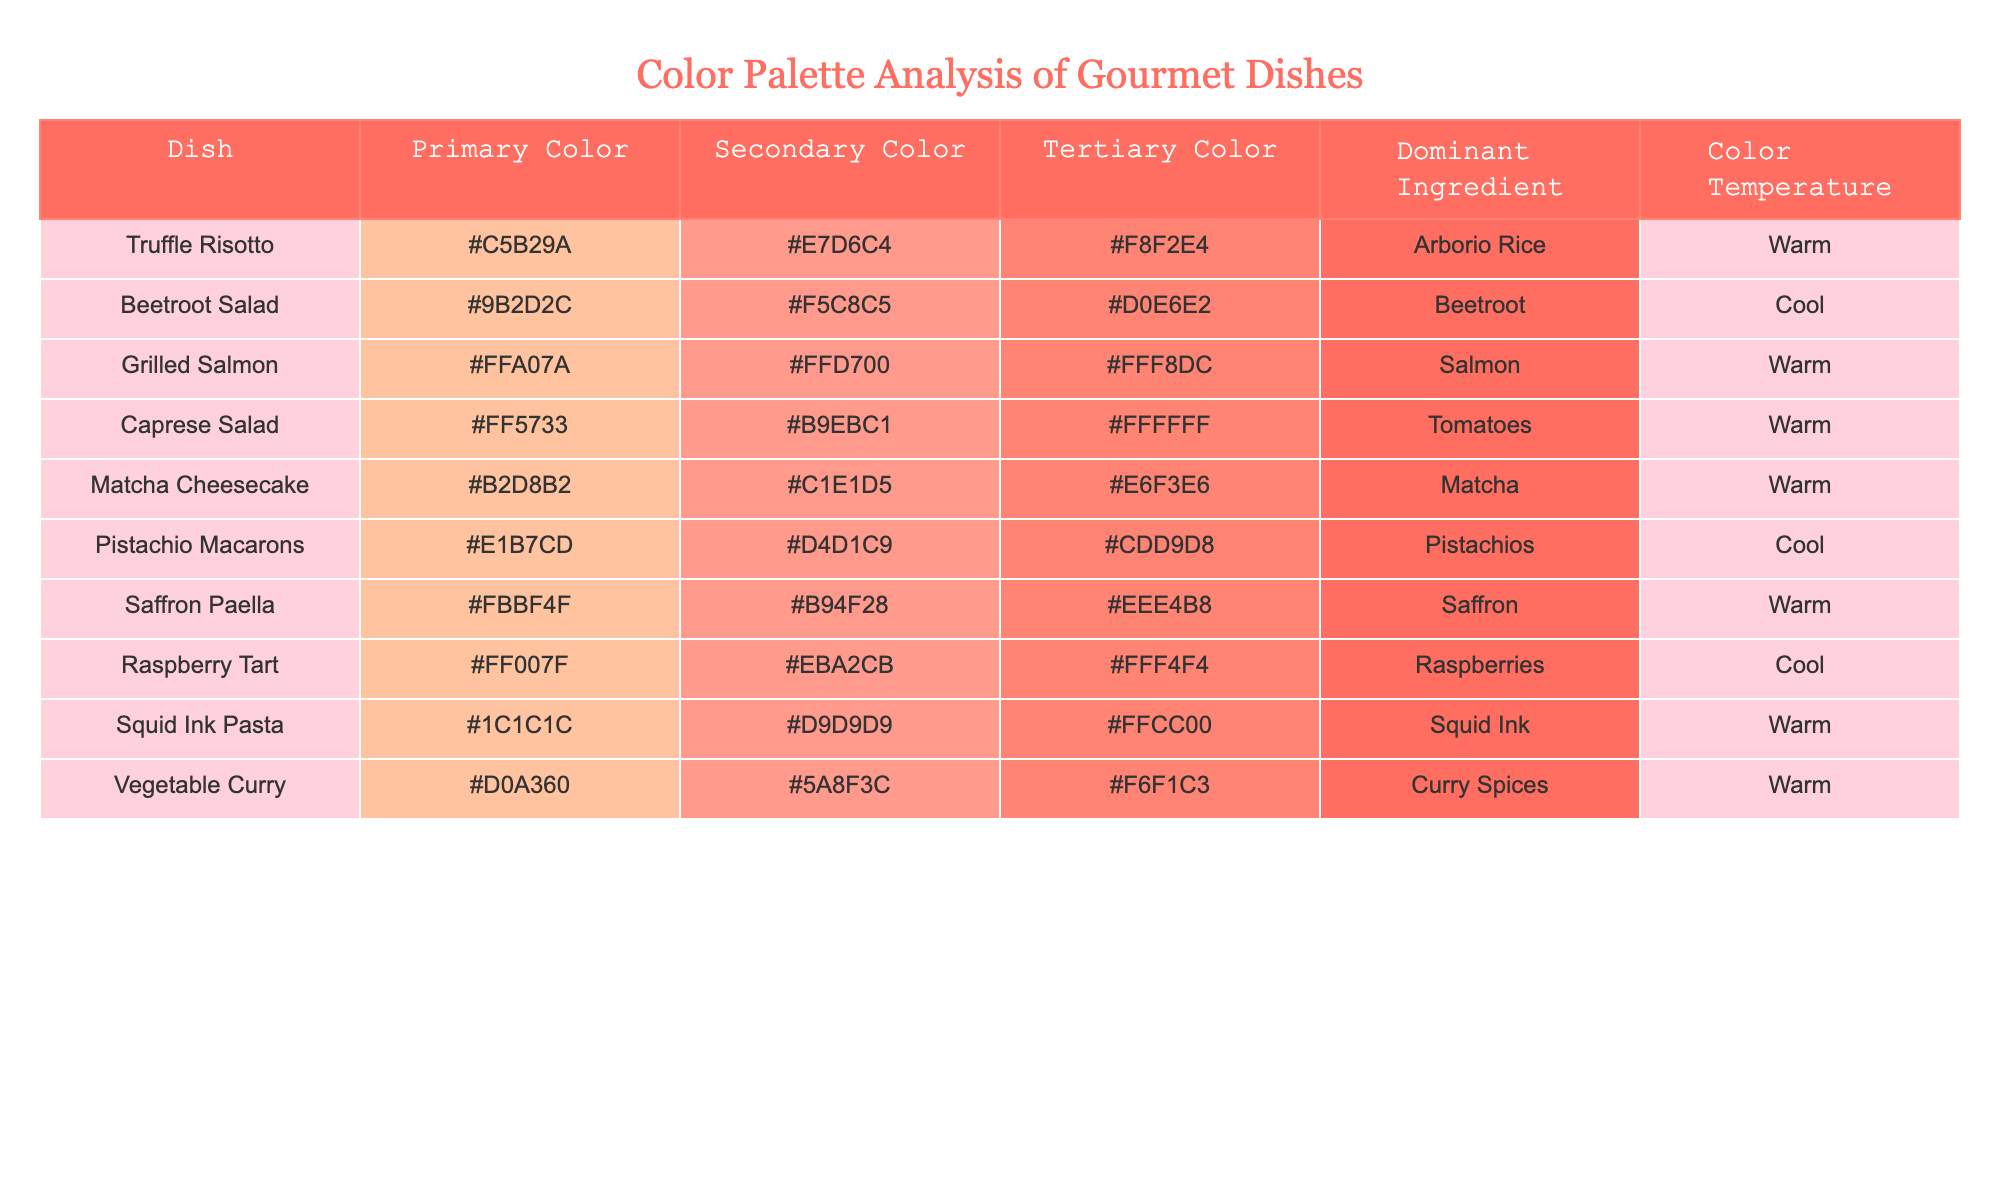What is the primary color of the Grilled Salmon dish? The Grilled Salmon dish has the primary color listed as #FFA07A. I can find this by locating the row for Grilled Salmon in the table and checking the value in the Primary Color column.
Answer: #FFA07A How many dishes have a cool color temperature? There are two dishes in the table classified under a cool color temperature: Beetroot Salad and Raspberry Tart. I can find this by scanning the Color Temperature column and counting the rows labeled 'Cool'.
Answer: 2 Is the dominant ingredient in the Caprese Salad tomatoes? Yes, the dominant ingredient for Caprese Salad is indeed listed as Tomatoes. I can verify this by looking at the row for Caprese Salad in the table and checking the value in the Dominant Ingredient column.
Answer: Yes What is the average color temperature of the dishes listed? The average color temperature cannot be numerically derived as the values are categorical (Warm and Cool). However, I can identify that the majority are Warm, with 8 dishes out of 10 being classified as Warm. This is a qualitative observation rather than a numeric average.
Answer: Not applicable Which dish has the most dominant warm color palette? The dish with the most dominant warm color palette is likely to be Saffron Paella, as it has the strongest warm tone with its primary color #FBBF4F. To reach this conclusion, I would compare the primary colors of all warm dishes and identify the one with the most pronounced warm color.
Answer: Saffron Paella Are there any dishes with a tertiary color that is predominantly white? Yes, there are two dishes that have a tertiary color that is predominantly white: Caprese Salad and Squid Ink Pasta. I can find this by looking for the tertiary color column and checking for white values (#FFFFFF).
Answer: Yes Which dish has the highest secondary color brightness? The dish with the highest secondary color brightness is Truffle Risotto with a secondary color of #E7D6C4. To find this, I would compare the secondary color hex values by analyzing their perceived brightness.
Answer: Truffle Risotto Is the color palette of the Vegetable Curry warm or cool? The color palette of the Vegetable Curry is classified as warm, as indicated in the Color Temperature column of the table. I can confirm this by locating the row for Vegetable Curry and checking its color temperature classification.
Answer: Warm 